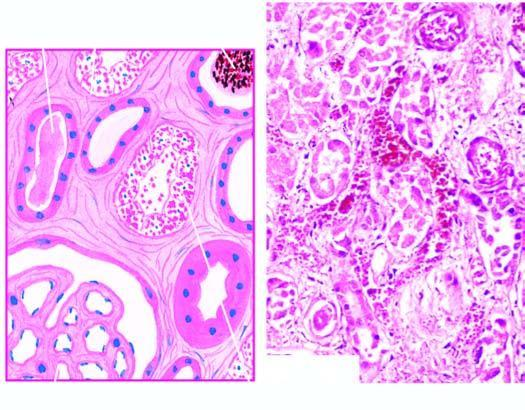do the infarcted area contain casts?
Answer the question using a single word or phrase. No 